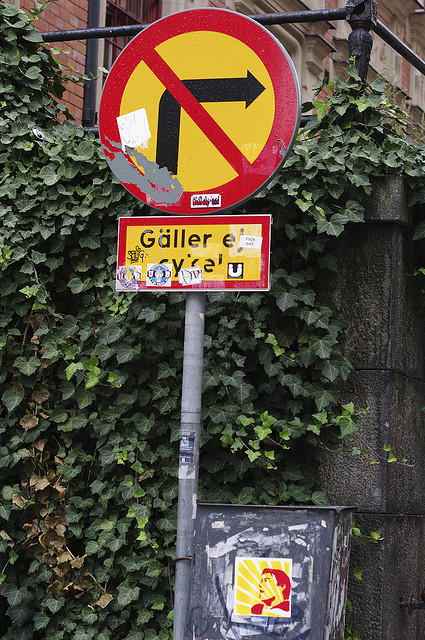Please extract the text content from this image. Galler ej U 